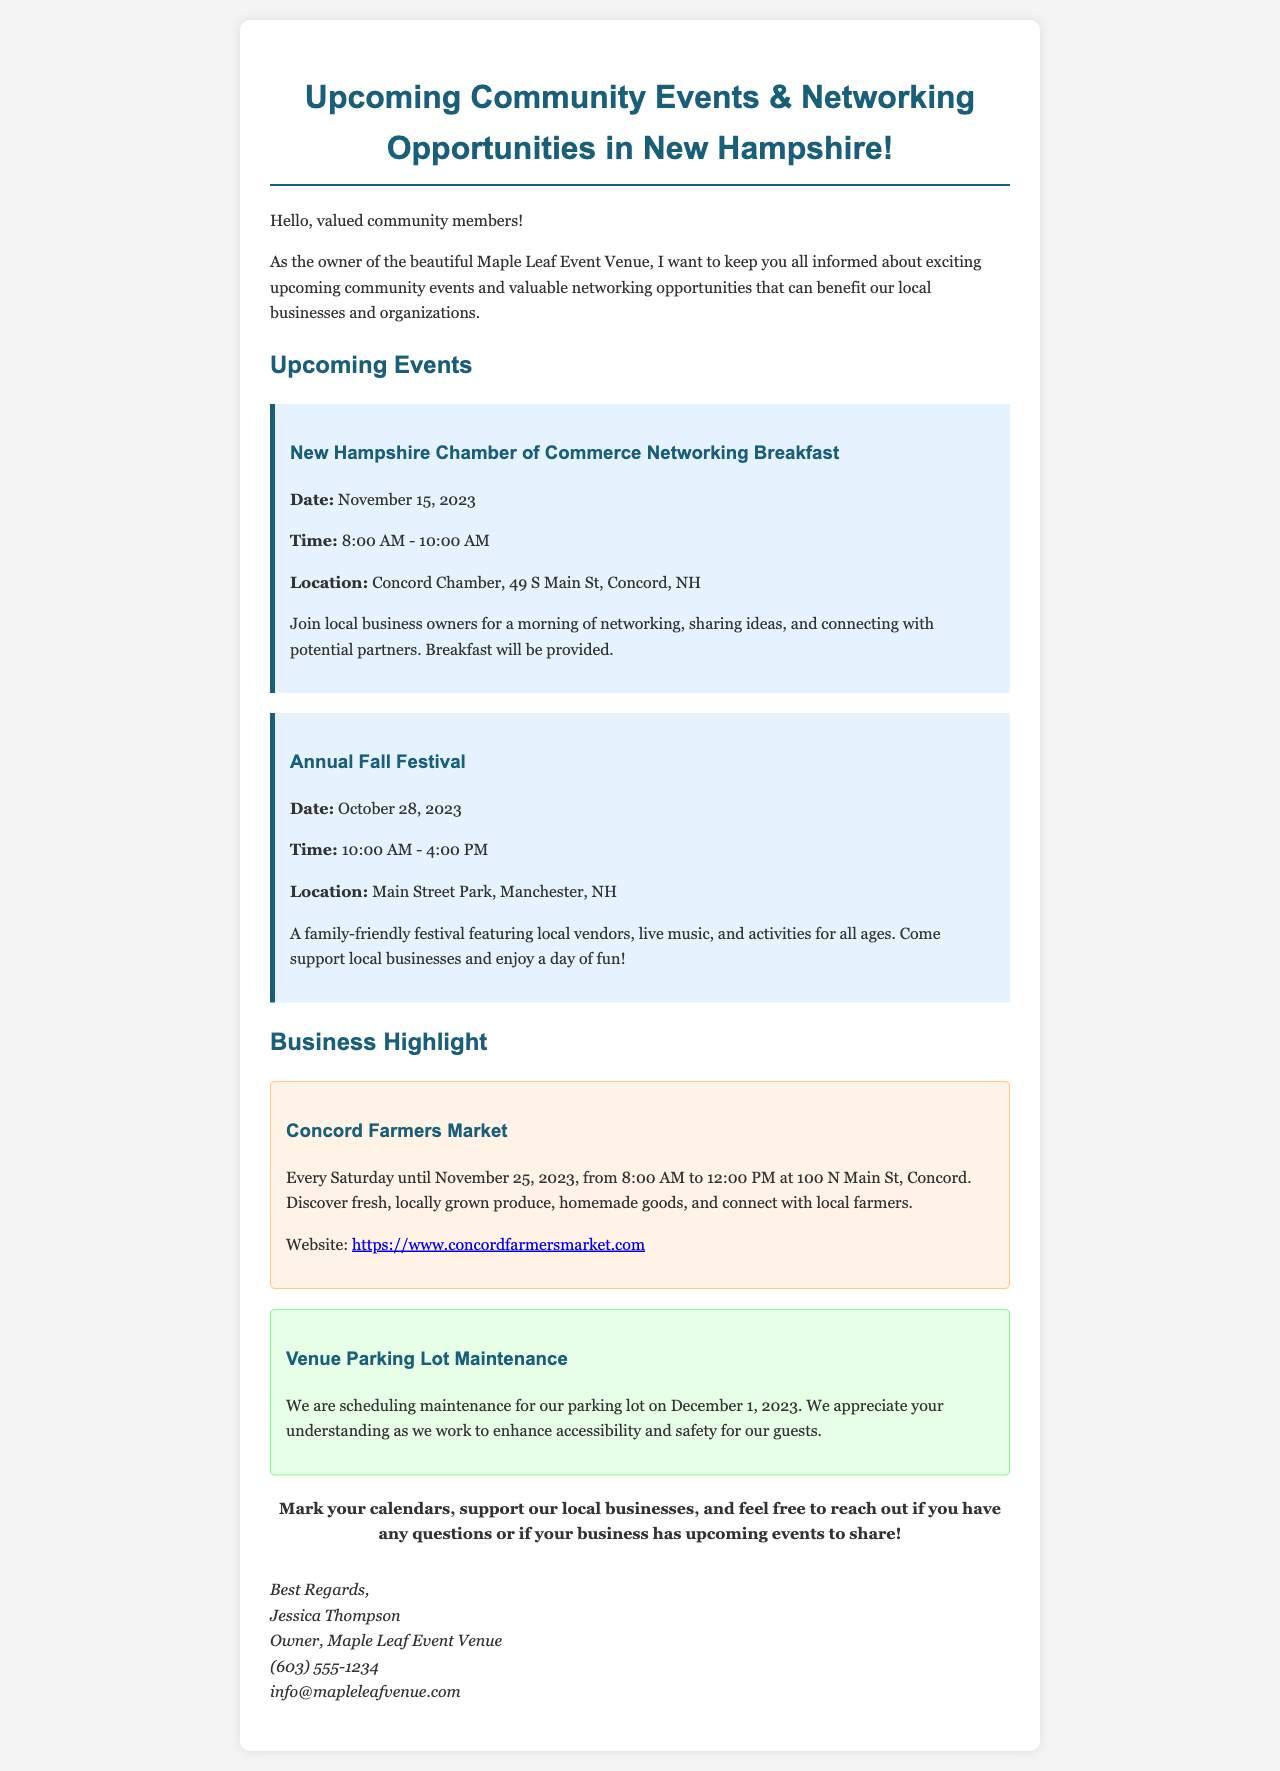What is the date of the Networking Breakfast? The date is specifically mentioned under the "Upcoming Events" section for the Networking Breakfast.
Answer: November 15, 2023 What time does the Annual Fall Festival start? The starting time is clearly stated in the event details for the Annual Fall Festival.
Answer: 10:00 AM Which event is taking place on October 28, 2023? This is found in the "Upcoming Events" section and explicitly mentions the date and event name.
Answer: Annual Fall Festival What is being highlighted in the Business Highlight section? The section specifies which business is highlighted and provides its name at the top.
Answer: Concord Farmers Market What maintenance is scheduled for December 1, 2023? The document outlines upcoming maintenance tasks in a distinct section dedicated to updates about the venue.
Answer: Parking lot maintenance What is the venue's contact email? The contact email is provided in the signature section of the document.
Answer: info@mapleleafvenue.com How long will the Concord Farmers Market run? The duration is mentioned in the context of the market schedule, indicating until a specific date.
Answer: Until November 25, 2023 Where is the Networking Breakfast held? The location is provided in the event details for the Networking Breakfast, including the full address.
Answer: Concord Chamber, 49 S Main St, Concord, NH 